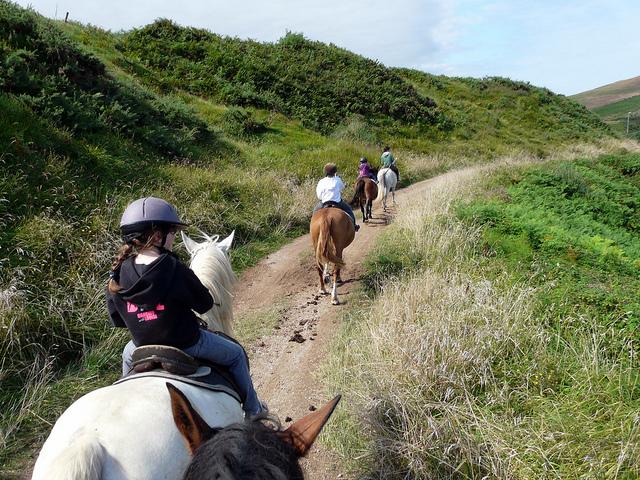What is on the little girl's head?
Answer briefly. Helmet. How many people are there?
Answer briefly. 4. Are they riding on a horse trail?
Short answer required. Yes. 